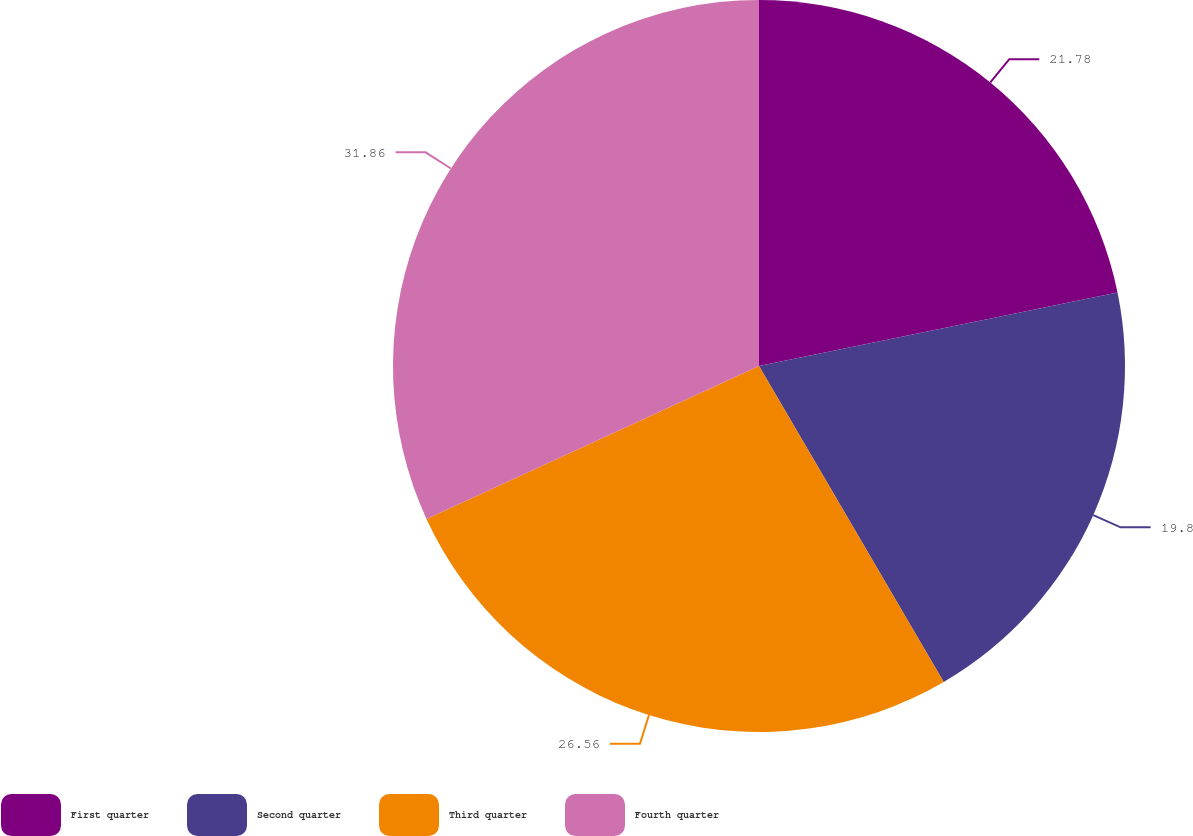Convert chart. <chart><loc_0><loc_0><loc_500><loc_500><pie_chart><fcel>First quarter<fcel>Second quarter<fcel>Third quarter<fcel>Fourth quarter<nl><fcel>21.78%<fcel>19.8%<fcel>26.56%<fcel>31.86%<nl></chart> 